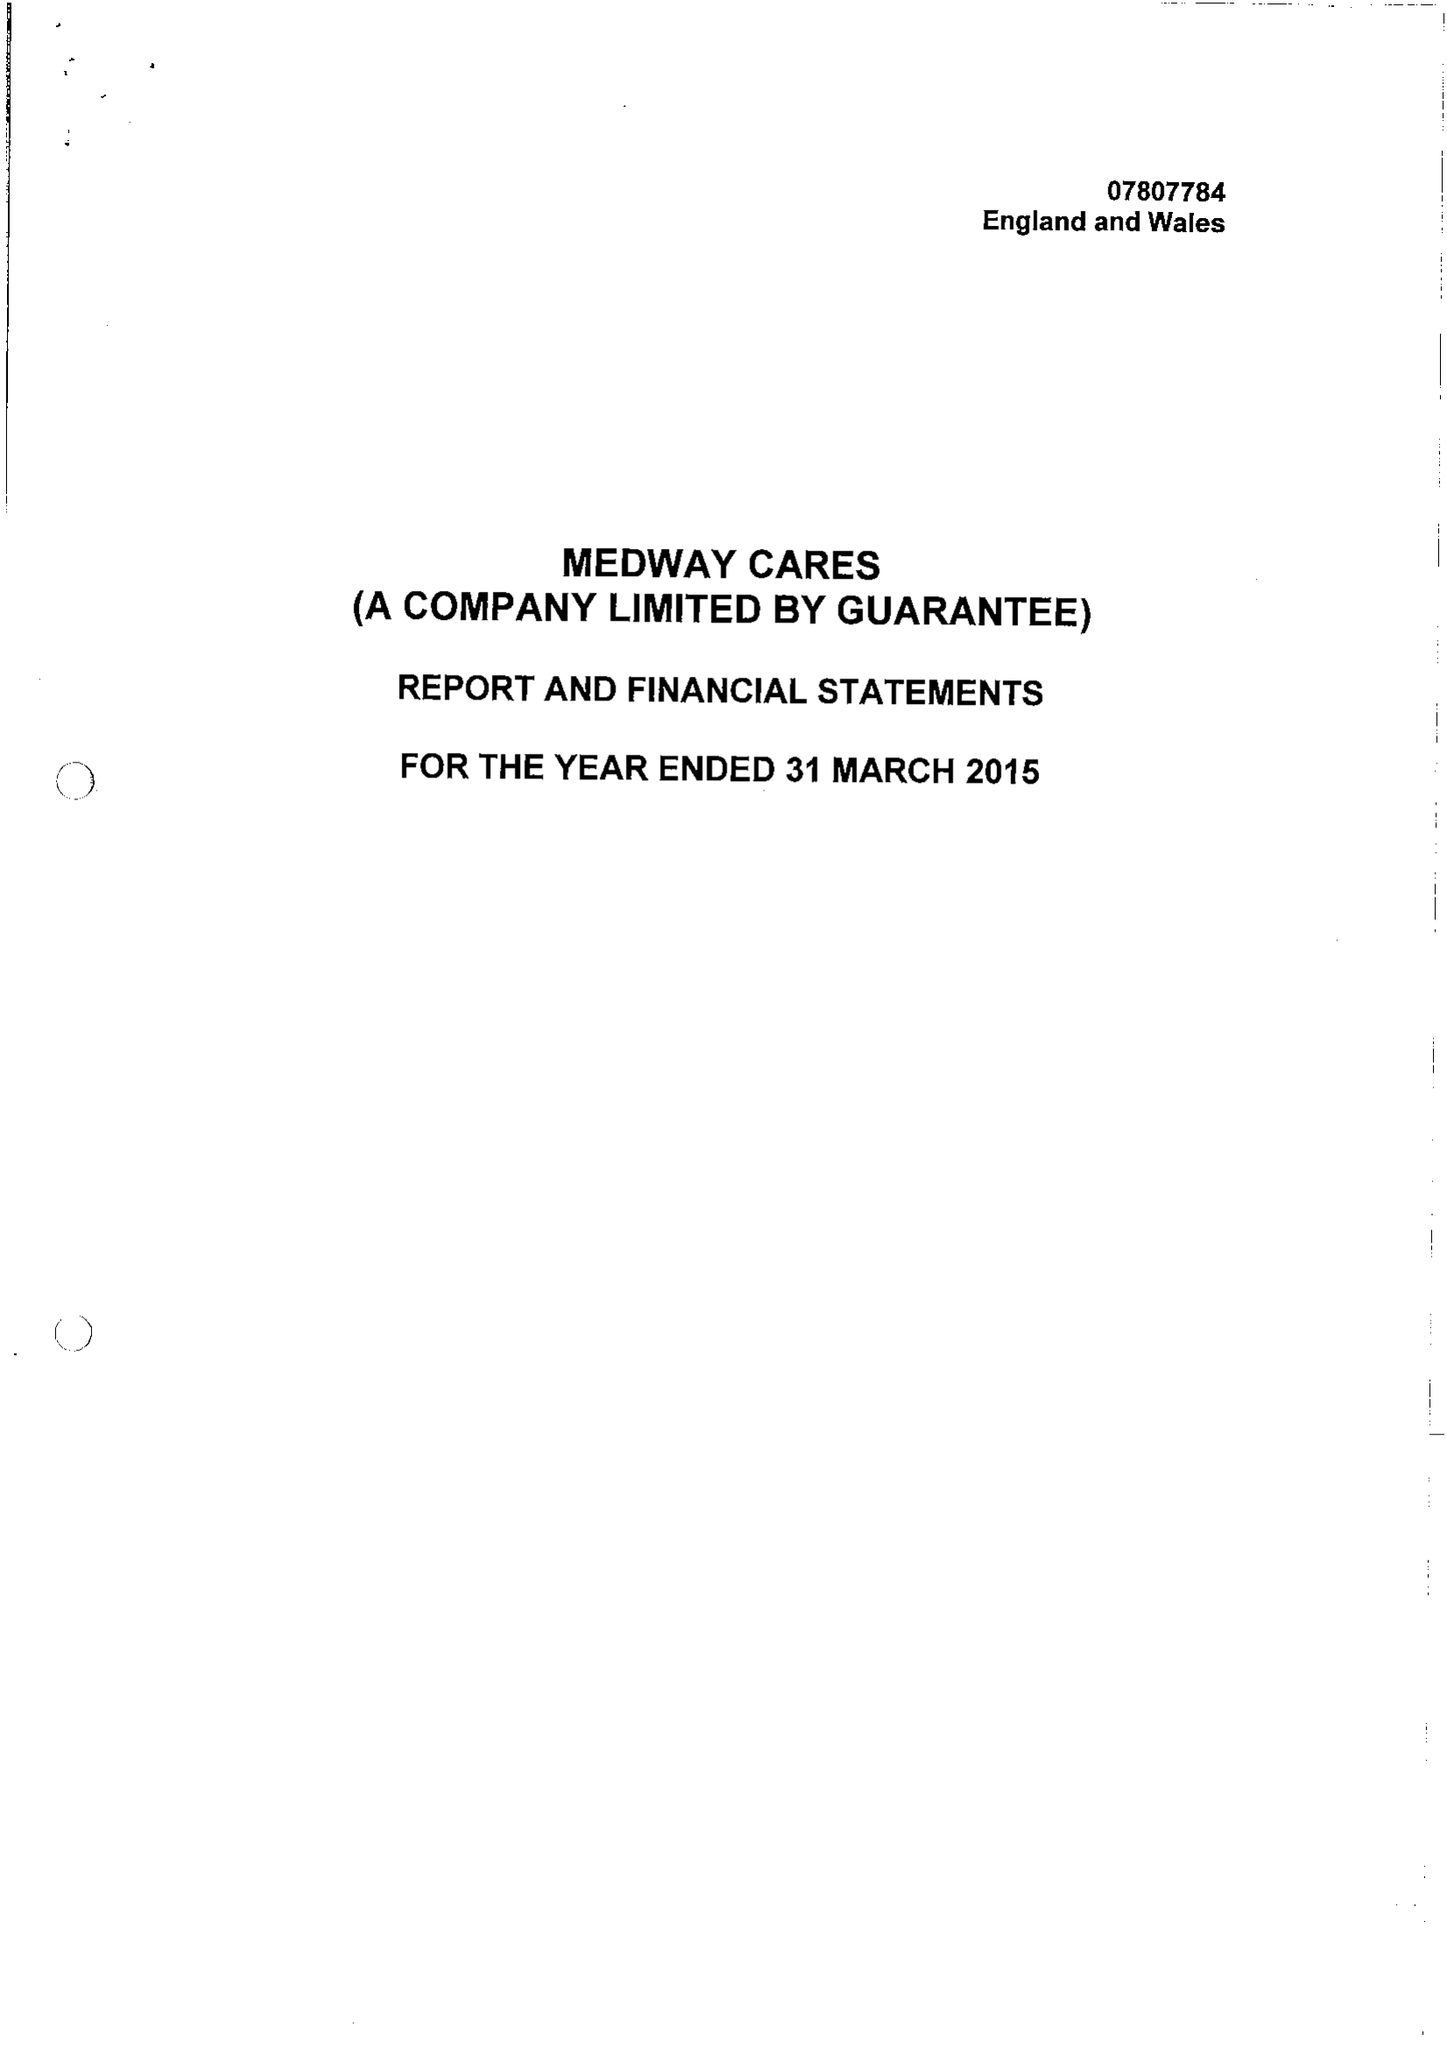What is the value for the address__postcode?
Answer the question using a single word or phrase. ME8 0PZ 